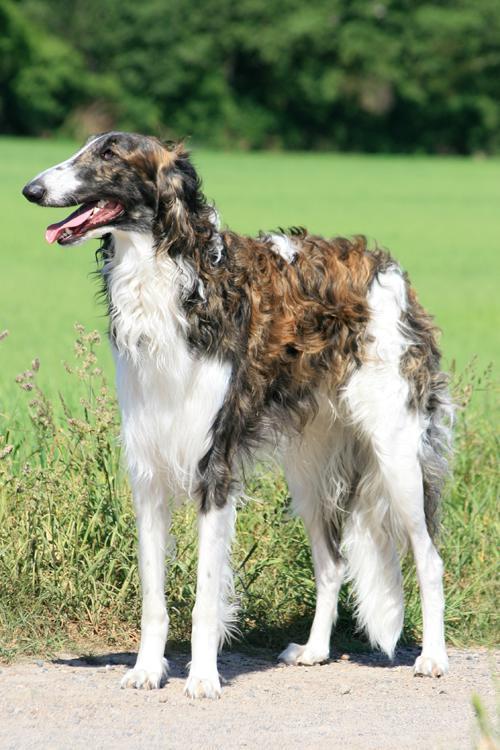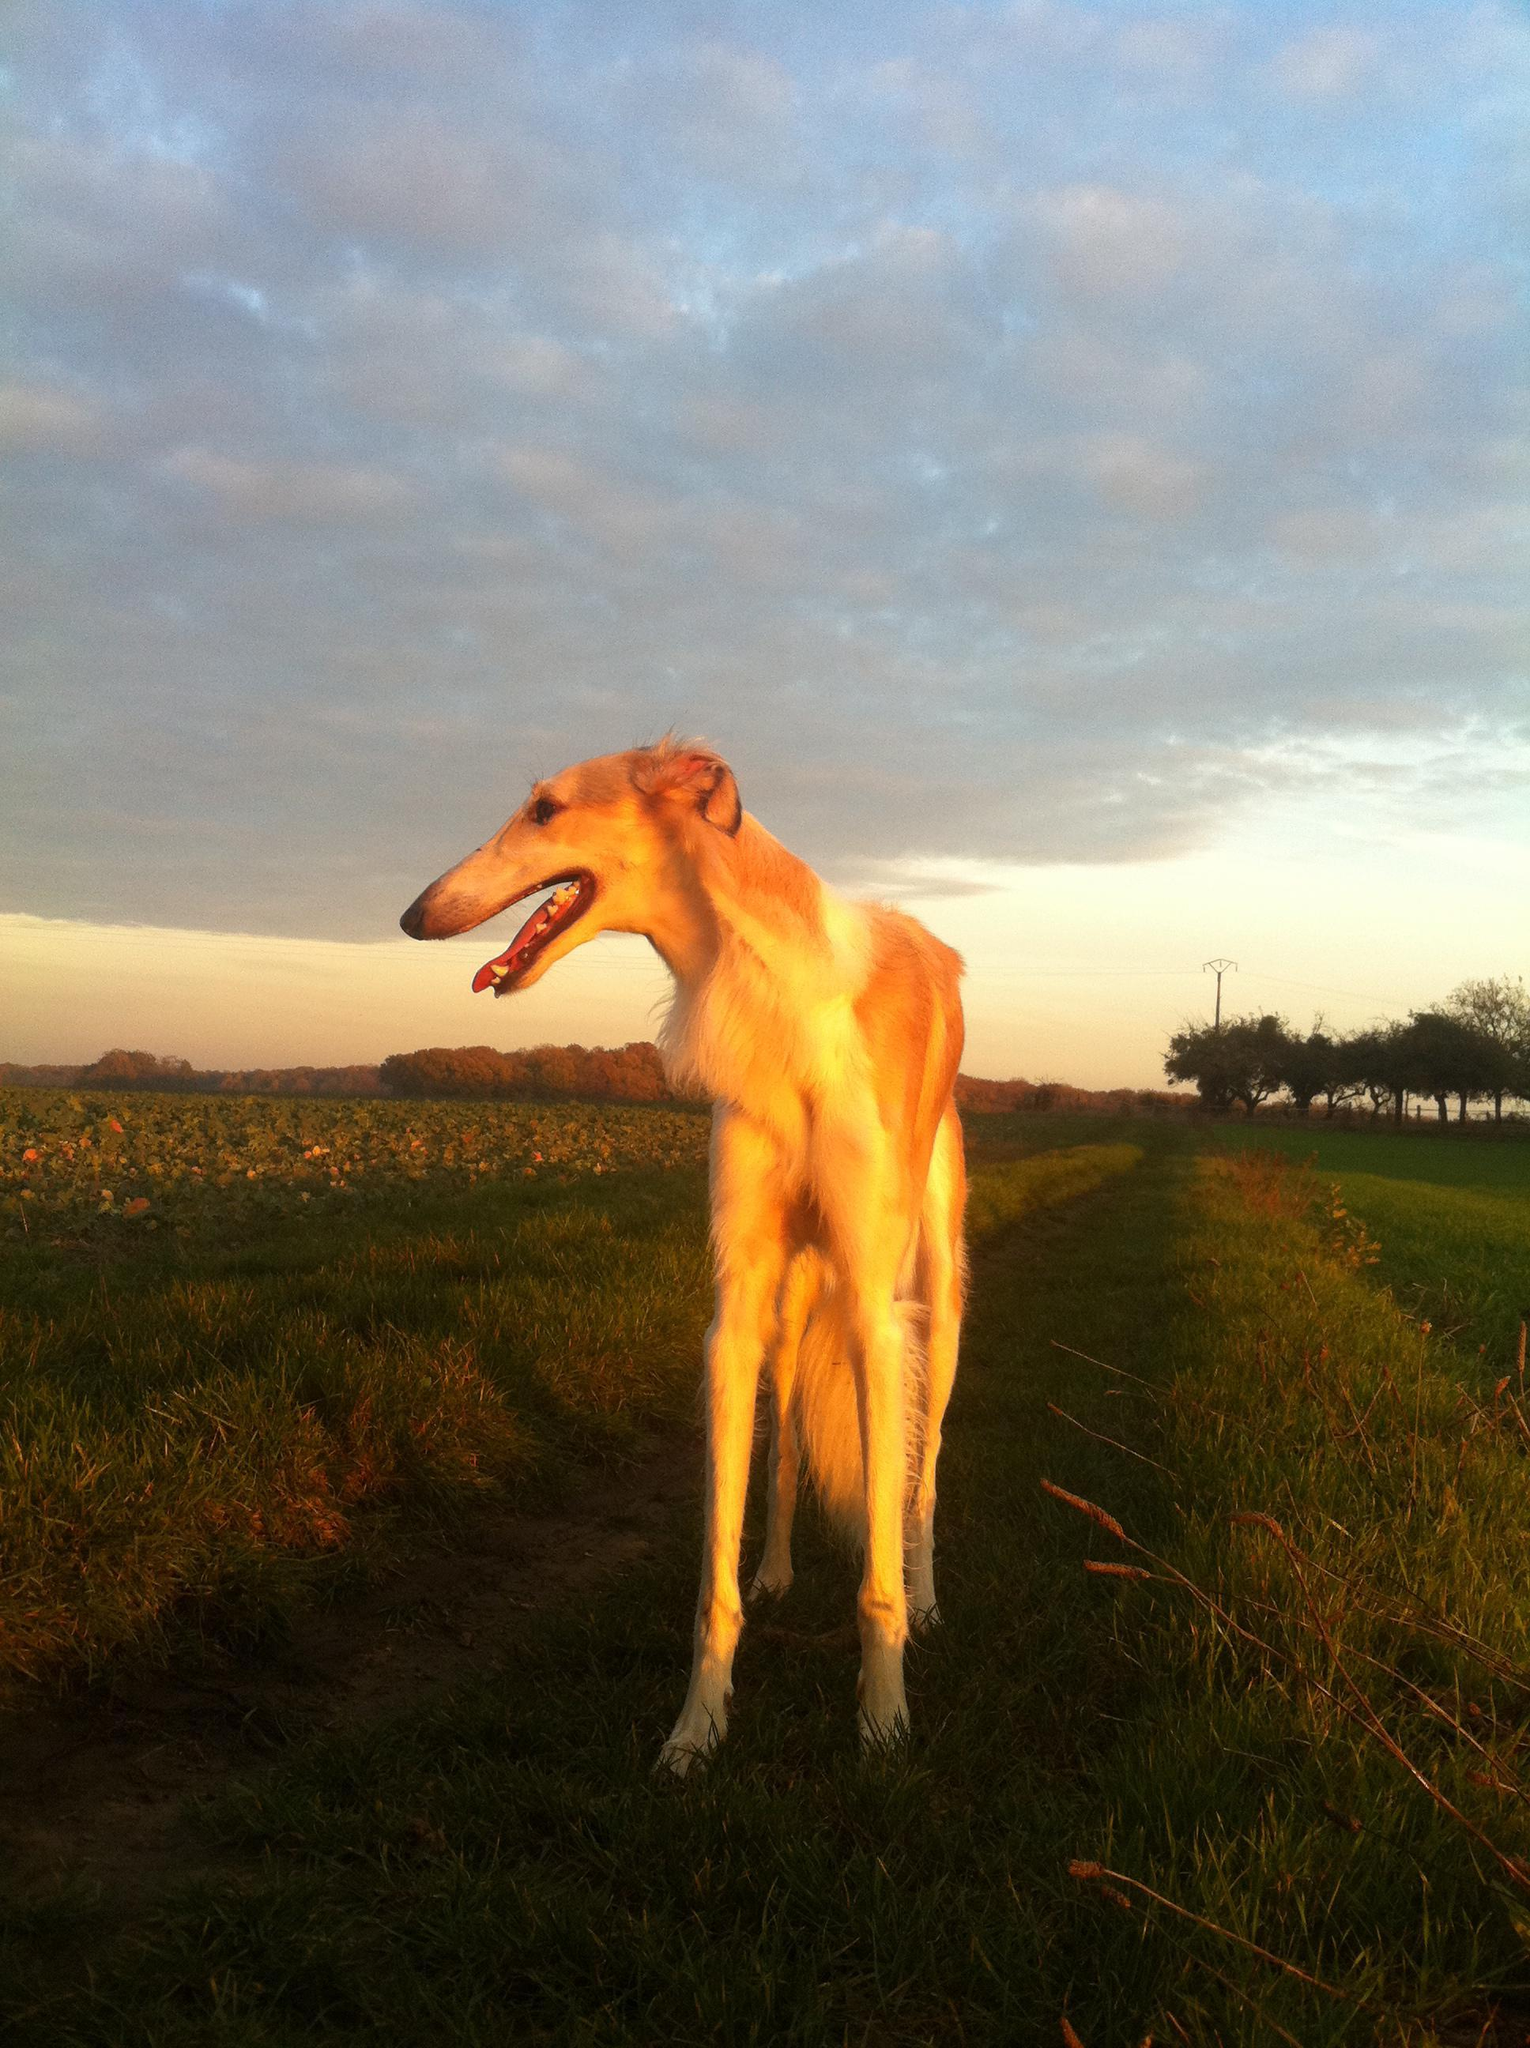The first image is the image on the left, the second image is the image on the right. Given the left and right images, does the statement "An image includes at least one person standing behind a standing afghan hound outdoors." hold true? Answer yes or no. No. The first image is the image on the left, the second image is the image on the right. Assess this claim about the two images: "There are exactly two dogs in total.". Correct or not? Answer yes or no. Yes. 